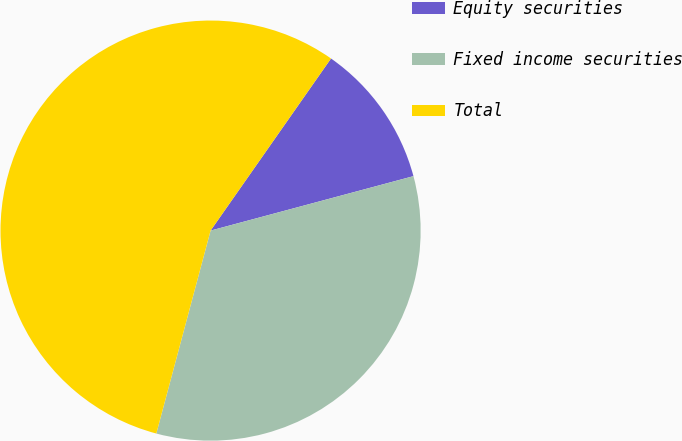<chart> <loc_0><loc_0><loc_500><loc_500><pie_chart><fcel>Equity securities<fcel>Fixed income securities<fcel>Total<nl><fcel>11.11%<fcel>33.33%<fcel>55.56%<nl></chart> 